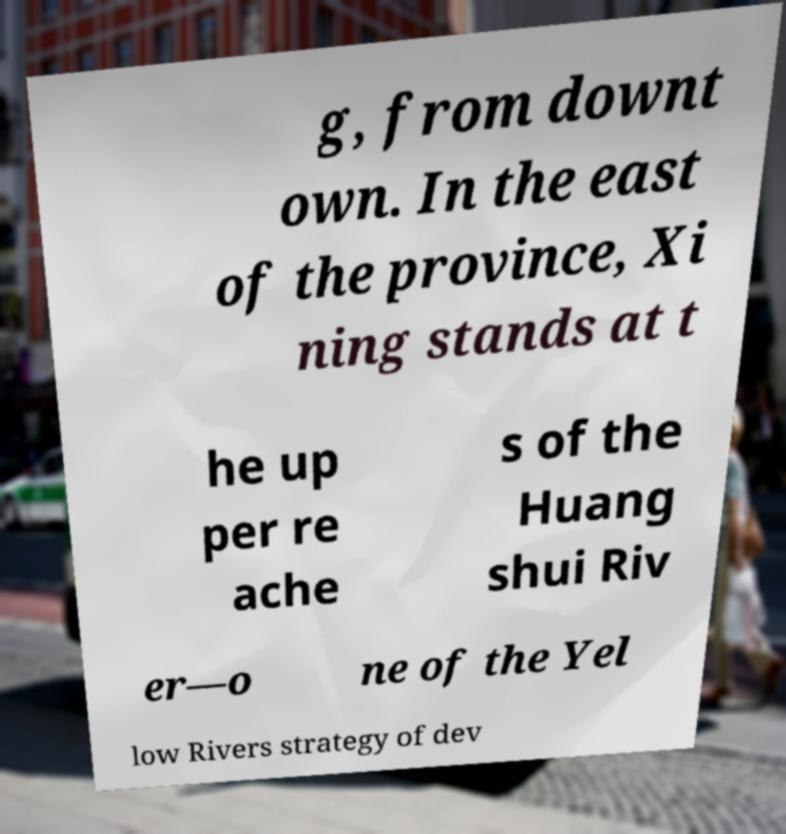Could you assist in decoding the text presented in this image and type it out clearly? g, from downt own. In the east of the province, Xi ning stands at t he up per re ache s of the Huang shui Riv er—o ne of the Yel low Rivers strategy of dev 